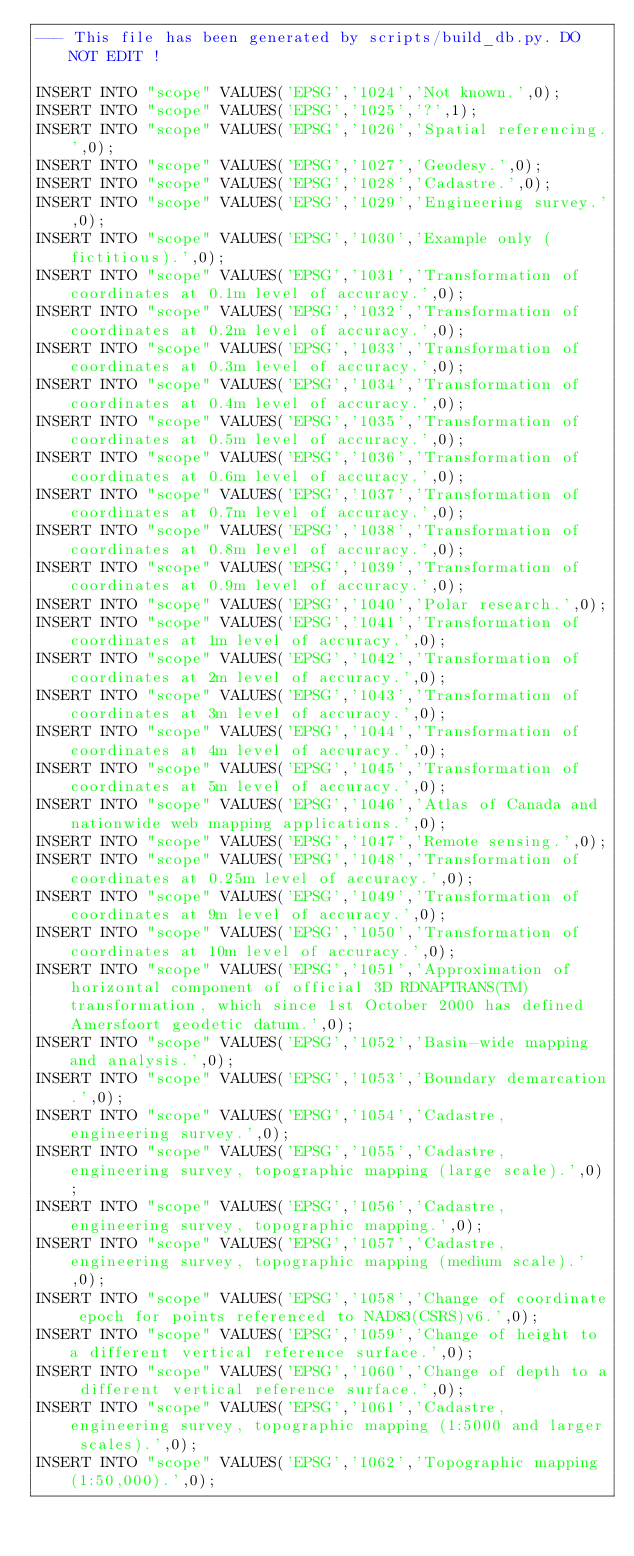Convert code to text. <code><loc_0><loc_0><loc_500><loc_500><_SQL_>--- This file has been generated by scripts/build_db.py. DO NOT EDIT !

INSERT INTO "scope" VALUES('EPSG','1024','Not known.',0);
INSERT INTO "scope" VALUES('EPSG','1025','?',1);
INSERT INTO "scope" VALUES('EPSG','1026','Spatial referencing.',0);
INSERT INTO "scope" VALUES('EPSG','1027','Geodesy.',0);
INSERT INTO "scope" VALUES('EPSG','1028','Cadastre.',0);
INSERT INTO "scope" VALUES('EPSG','1029','Engineering survey.',0);
INSERT INTO "scope" VALUES('EPSG','1030','Example only (fictitious).',0);
INSERT INTO "scope" VALUES('EPSG','1031','Transformation of coordinates at 0.1m level of accuracy.',0);
INSERT INTO "scope" VALUES('EPSG','1032','Transformation of coordinates at 0.2m level of accuracy.',0);
INSERT INTO "scope" VALUES('EPSG','1033','Transformation of coordinates at 0.3m level of accuracy.',0);
INSERT INTO "scope" VALUES('EPSG','1034','Transformation of coordinates at 0.4m level of accuracy.',0);
INSERT INTO "scope" VALUES('EPSG','1035','Transformation of coordinates at 0.5m level of accuracy.',0);
INSERT INTO "scope" VALUES('EPSG','1036','Transformation of coordinates at 0.6m level of accuracy.',0);
INSERT INTO "scope" VALUES('EPSG','1037','Transformation of coordinates at 0.7m level of accuracy.',0);
INSERT INTO "scope" VALUES('EPSG','1038','Transformation of coordinates at 0.8m level of accuracy.',0);
INSERT INTO "scope" VALUES('EPSG','1039','Transformation of coordinates at 0.9m level of accuracy.',0);
INSERT INTO "scope" VALUES('EPSG','1040','Polar research.',0);
INSERT INTO "scope" VALUES('EPSG','1041','Transformation of coordinates at 1m level of accuracy.',0);
INSERT INTO "scope" VALUES('EPSG','1042','Transformation of coordinates at 2m level of accuracy.',0);
INSERT INTO "scope" VALUES('EPSG','1043','Transformation of coordinates at 3m level of accuracy.',0);
INSERT INTO "scope" VALUES('EPSG','1044','Transformation of coordinates at 4m level of accuracy.',0);
INSERT INTO "scope" VALUES('EPSG','1045','Transformation of coordinates at 5m level of accuracy.',0);
INSERT INTO "scope" VALUES('EPSG','1046','Atlas of Canada and nationwide web mapping applications.',0);
INSERT INTO "scope" VALUES('EPSG','1047','Remote sensing.',0);
INSERT INTO "scope" VALUES('EPSG','1048','Transformation of coordinates at 0.25m level of accuracy.',0);
INSERT INTO "scope" VALUES('EPSG','1049','Transformation of coordinates at 9m level of accuracy.',0);
INSERT INTO "scope" VALUES('EPSG','1050','Transformation of coordinates at 10m level of accuracy.',0);
INSERT INTO "scope" VALUES('EPSG','1051','Approximation of horizontal component of official 3D RDNAPTRANS(TM) transformation, which since 1st October 2000 has defined Amersfoort geodetic datum.',0);
INSERT INTO "scope" VALUES('EPSG','1052','Basin-wide mapping and analysis.',0);
INSERT INTO "scope" VALUES('EPSG','1053','Boundary demarcation.',0);
INSERT INTO "scope" VALUES('EPSG','1054','Cadastre, engineering survey.',0);
INSERT INTO "scope" VALUES('EPSG','1055','Cadastre, engineering survey, topographic mapping (large scale).',0);
INSERT INTO "scope" VALUES('EPSG','1056','Cadastre, engineering survey, topographic mapping.',0);
INSERT INTO "scope" VALUES('EPSG','1057','Cadastre, engineering survey, topographic mapping (medium scale).',0);
INSERT INTO "scope" VALUES('EPSG','1058','Change of coordinate epoch for points referenced to NAD83(CSRS)v6.',0);
INSERT INTO "scope" VALUES('EPSG','1059','Change of height to a different vertical reference surface.',0);
INSERT INTO "scope" VALUES('EPSG','1060','Change of depth to a different vertical reference surface.',0);
INSERT INTO "scope" VALUES('EPSG','1061','Cadastre, engineering survey, topographic mapping (1:5000 and larger scales).',0);
INSERT INTO "scope" VALUES('EPSG','1062','Topographic mapping (1:50,000).',0);</code> 